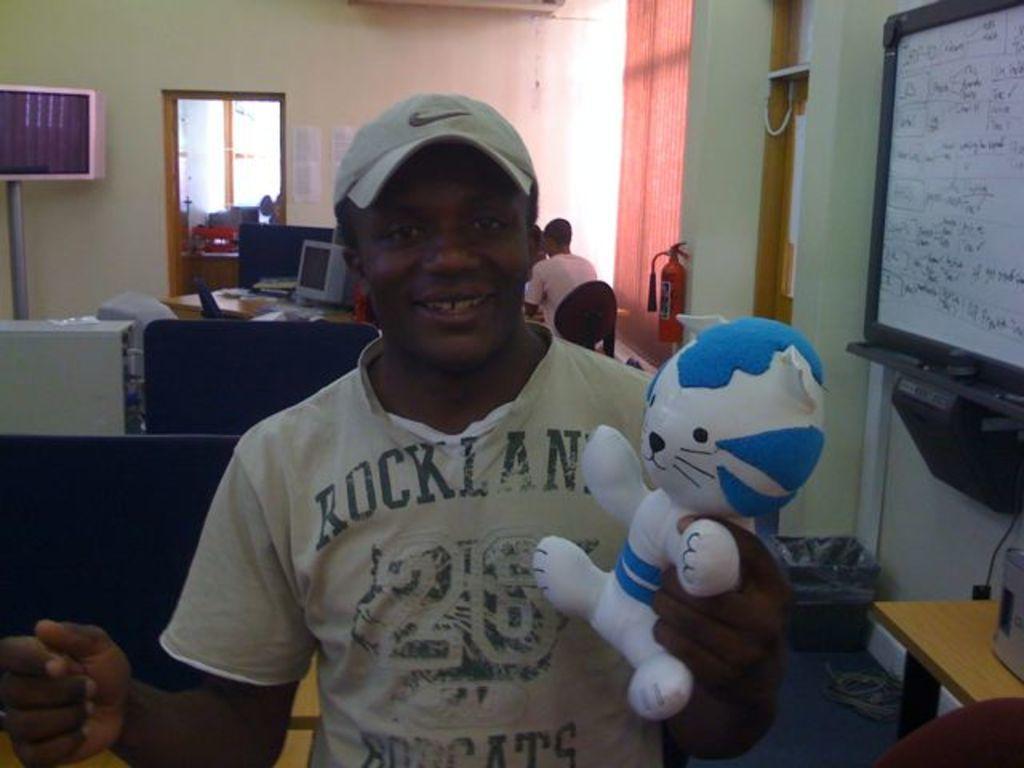In one or two sentences, can you explain what this image depicts? The person wearing hat is holding a toy in his hand and there is a person sitting behind him and there is a whiteboard beside him which has some thing written on it. 